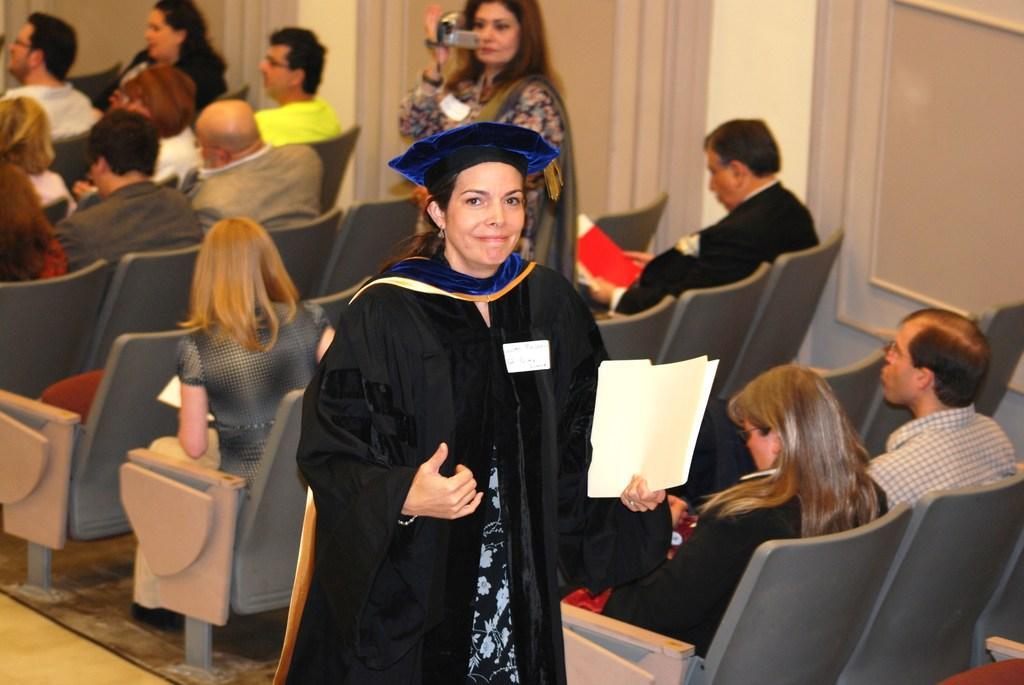Please provide a concise description of this image. In front of the image there is a person holding the papers. Behind her there is another person holding the camera. There are a few people sitting on the chairs. In the background of the image there is a wall. At the bottom of the image there is a mat on the floor. 